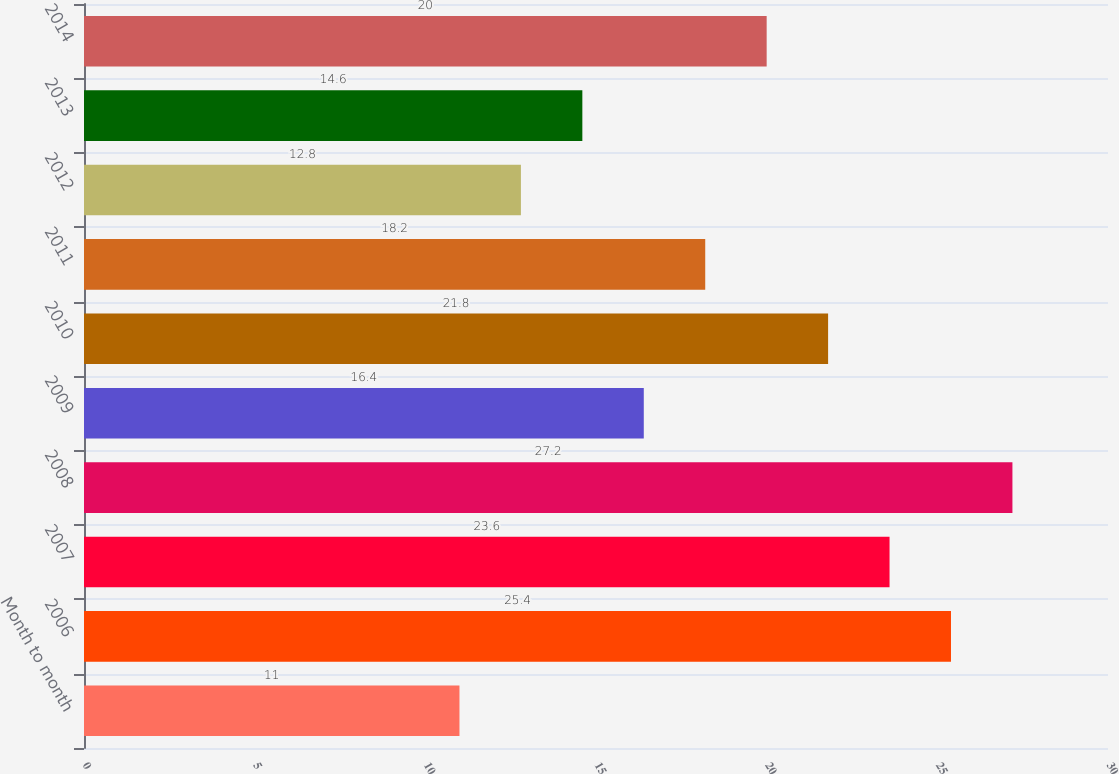Convert chart to OTSL. <chart><loc_0><loc_0><loc_500><loc_500><bar_chart><fcel>Month to month<fcel>2006<fcel>2007<fcel>2008<fcel>2009<fcel>2010<fcel>2011<fcel>2012<fcel>2013<fcel>2014<nl><fcel>11<fcel>25.4<fcel>23.6<fcel>27.2<fcel>16.4<fcel>21.8<fcel>18.2<fcel>12.8<fcel>14.6<fcel>20<nl></chart> 